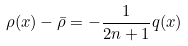Convert formula to latex. <formula><loc_0><loc_0><loc_500><loc_500>\rho ( x ) - \bar { \rho } = - \frac { 1 } { 2 n + 1 } q ( x )</formula> 